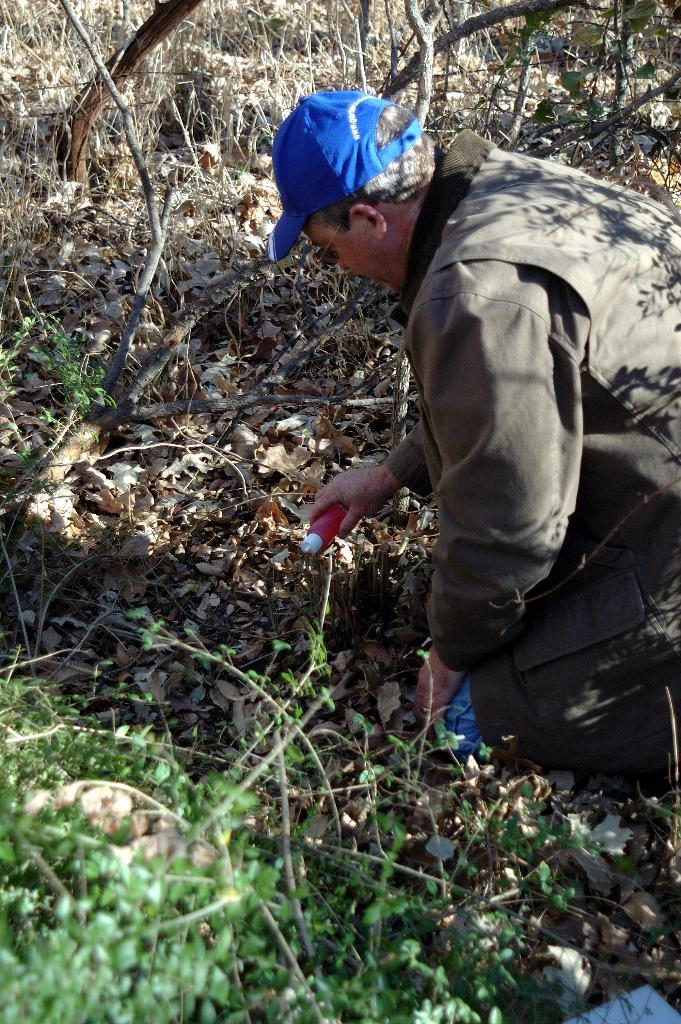What can be seen in the image? There is a person in the image. Can you describe the person's attire? The person is wearing a cap. What is the person holding in the image? The person is holding an object. What type of natural elements can be seen in the image? There are leaves on the ground, trees, and plants in the image. How does the person's anger increase throughout the image? There is no indication of the person's emotions in the image, so it cannot be determined if their anger is increasing or not. 